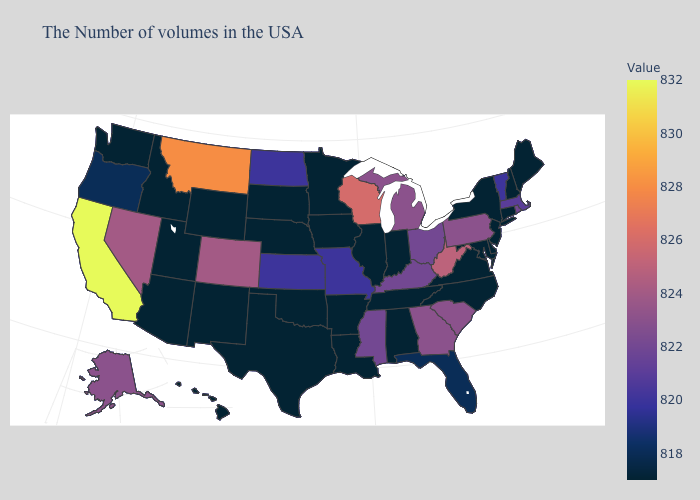Which states have the highest value in the USA?
Be succinct. California. Does Illinois have a lower value than Michigan?
Answer briefly. Yes. Does California have the highest value in the USA?
Keep it brief. Yes. Among the states that border Tennessee , does Virginia have the lowest value?
Give a very brief answer. Yes. Among the states that border Alabama , does Georgia have the lowest value?
Short answer required. No. Which states hav the highest value in the West?
Short answer required. California. Among the states that border Kansas , which have the lowest value?
Concise answer only. Nebraska, Oklahoma. Among the states that border Nebraska , which have the highest value?
Quick response, please. Colorado. 